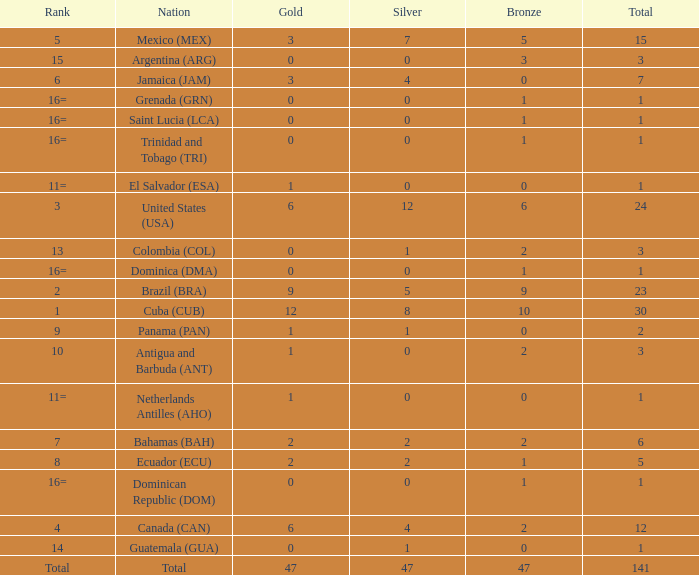How many bronzes have a Nation of jamaica (jam), and a Total smaller than 7? 0.0. Help me parse the entirety of this table. {'header': ['Rank', 'Nation', 'Gold', 'Silver', 'Bronze', 'Total'], 'rows': [['5', 'Mexico (MEX)', '3', '7', '5', '15'], ['15', 'Argentina (ARG)', '0', '0', '3', '3'], ['6', 'Jamaica (JAM)', '3', '4', '0', '7'], ['16=', 'Grenada (GRN)', '0', '0', '1', '1'], ['16=', 'Saint Lucia (LCA)', '0', '0', '1', '1'], ['16=', 'Trinidad and Tobago (TRI)', '0', '0', '1', '1'], ['11=', 'El Salvador (ESA)', '1', '0', '0', '1'], ['3', 'United States (USA)', '6', '12', '6', '24'], ['13', 'Colombia (COL)', '0', '1', '2', '3'], ['16=', 'Dominica (DMA)', '0', '0', '1', '1'], ['2', 'Brazil (BRA)', '9', '5', '9', '23'], ['1', 'Cuba (CUB)', '12', '8', '10', '30'], ['9', 'Panama (PAN)', '1', '1', '0', '2'], ['10', 'Antigua and Barbuda (ANT)', '1', '0', '2', '3'], ['11=', 'Netherlands Antilles (AHO)', '1', '0', '0', '1'], ['7', 'Bahamas (BAH)', '2', '2', '2', '6'], ['8', 'Ecuador (ECU)', '2', '2', '1', '5'], ['16=', 'Dominican Republic (DOM)', '0', '0', '1', '1'], ['4', 'Canada (CAN)', '6', '4', '2', '12'], ['14', 'Guatemala (GUA)', '0', '1', '0', '1'], ['Total', 'Total', '47', '47', '47', '141']]} 